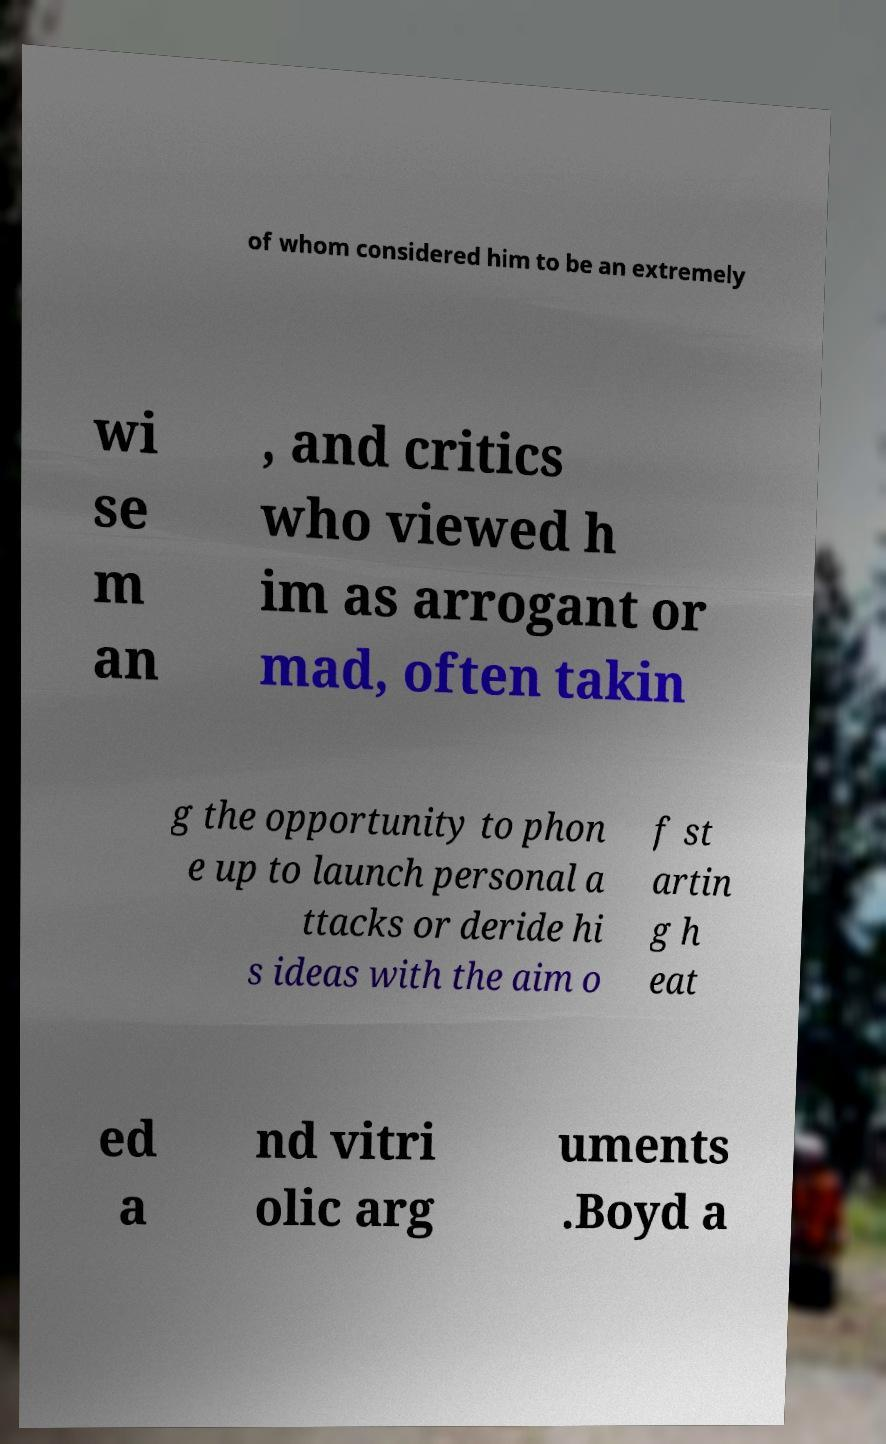Could you extract and type out the text from this image? of whom considered him to be an extremely wi se m an , and critics who viewed h im as arrogant or mad, often takin g the opportunity to phon e up to launch personal a ttacks or deride hi s ideas with the aim o f st artin g h eat ed a nd vitri olic arg uments .Boyd a 